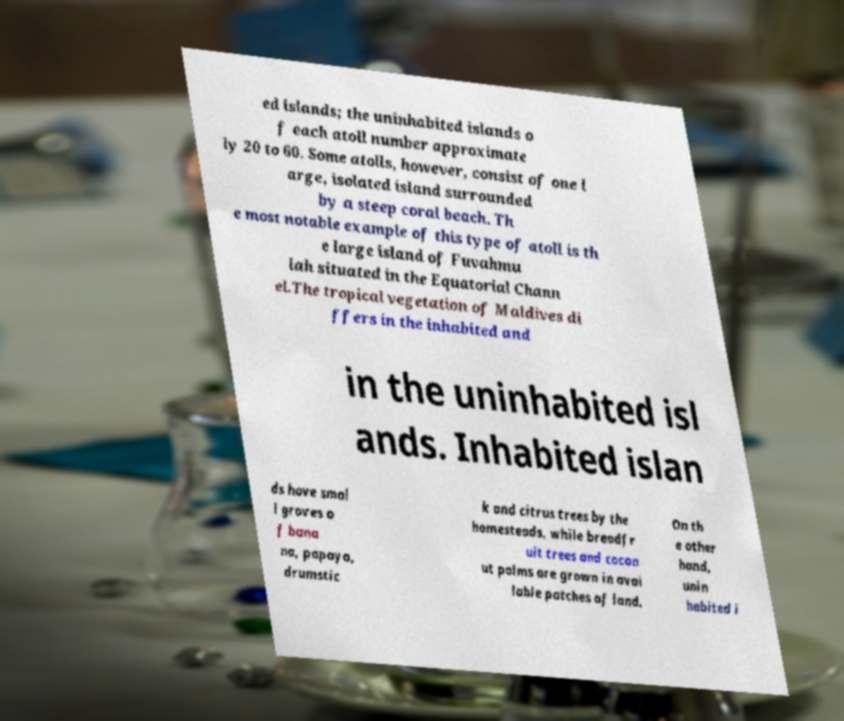What messages or text are displayed in this image? I need them in a readable, typed format. ed islands; the uninhabited islands o f each atoll number approximate ly 20 to 60. Some atolls, however, consist of one l arge, isolated island surrounded by a steep coral beach. Th e most notable example of this type of atoll is th e large island of Fuvahmu lah situated in the Equatorial Chann el.The tropical vegetation of Maldives di ffers in the inhabited and in the uninhabited isl ands. Inhabited islan ds have smal l groves o f bana na, papaya, drumstic k and citrus trees by the homesteads, while breadfr uit trees and cocon ut palms are grown in avai lable patches of land. On th e other hand, unin habited i 